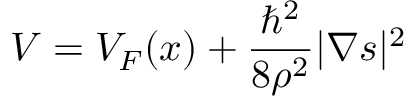Convert formula to latex. <formula><loc_0><loc_0><loc_500><loc_500>V = V _ { F } ( x ) + \frac { \hbar { ^ } { 2 } } { 8 \rho ^ { 2 } } | \nabla s | ^ { 2 }</formula> 